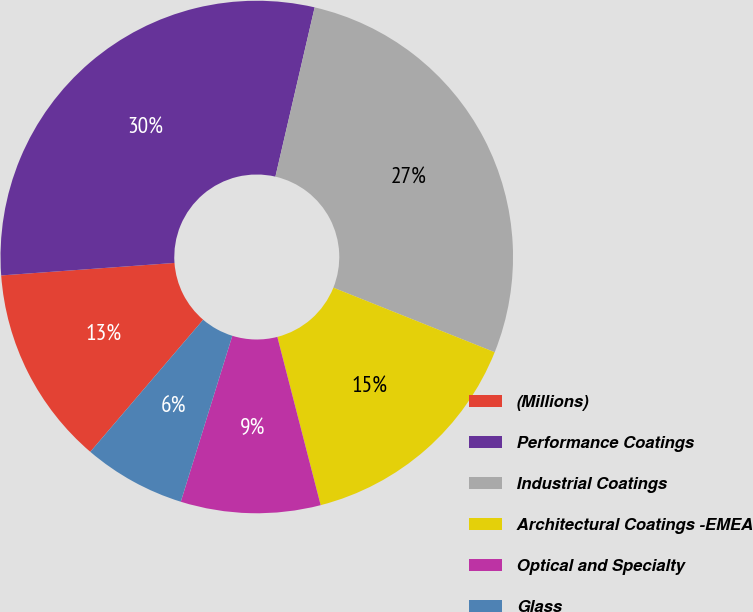<chart> <loc_0><loc_0><loc_500><loc_500><pie_chart><fcel>(Millions)<fcel>Performance Coatings<fcel>Industrial Coatings<fcel>Architectural Coatings -EMEA<fcel>Optical and Specialty<fcel>Glass<nl><fcel>12.6%<fcel>29.77%<fcel>27.43%<fcel>14.93%<fcel>8.8%<fcel>6.46%<nl></chart> 